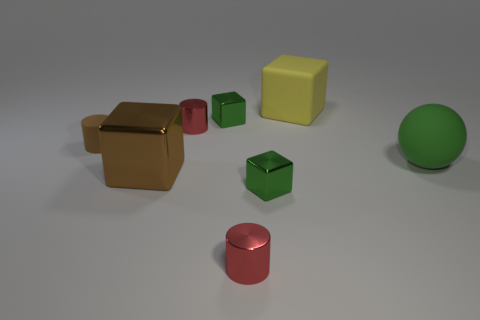Add 1 large green objects. How many objects exist? 9 Subtract all cylinders. How many objects are left? 5 Add 4 small matte objects. How many small matte objects are left? 5 Add 8 green rubber spheres. How many green rubber spheres exist? 9 Subtract 0 blue spheres. How many objects are left? 8 Subtract all blocks. Subtract all small matte objects. How many objects are left? 3 